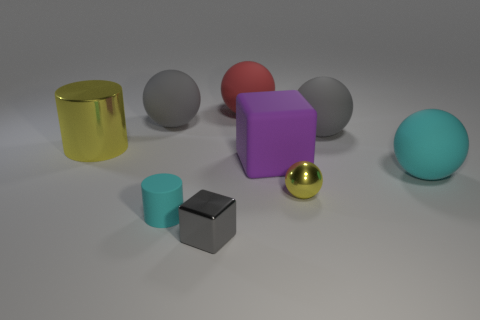Imagine these objects were part of a game, what could be the rules involving their colors and sizes? In a hypothetical game, one rule could be to match objects of similar colors and sizes. For instance, players might have to find pairs like the two gray objects or pair the golden items together. Another rule could involve sorting the objects from largest to smallest, or creating groups based on their textures—separating matte objects from shiny ones. 